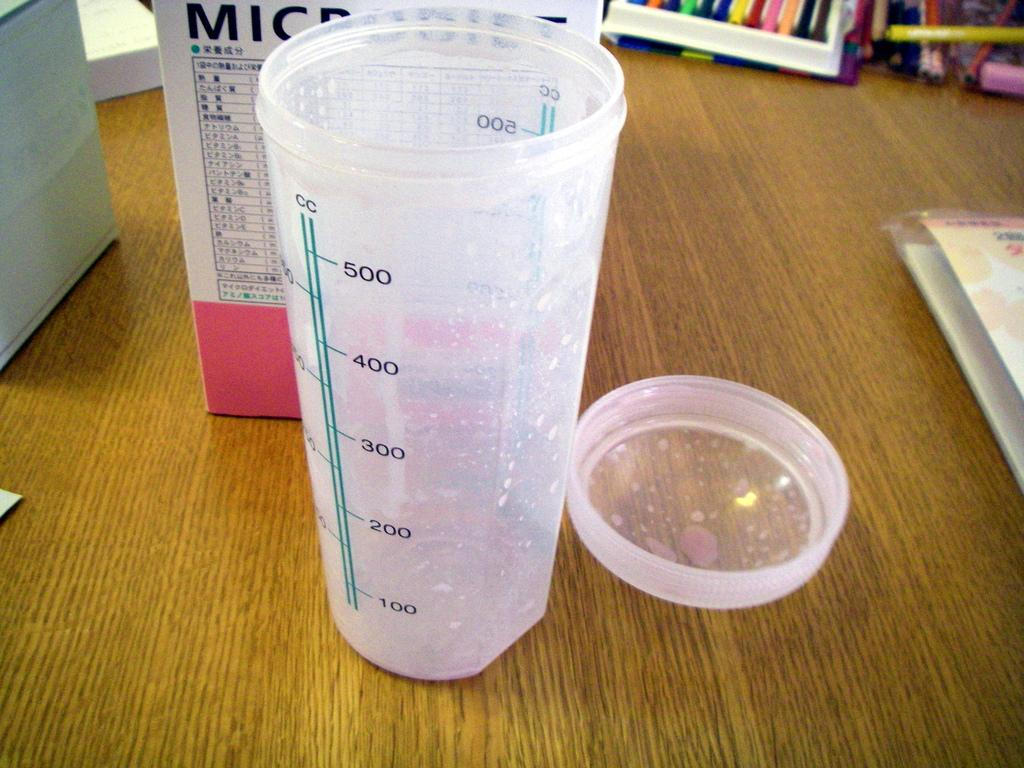<image>
Give a short and clear explanation of the subsequent image. A plastic container shows the number is CCs it contains. 